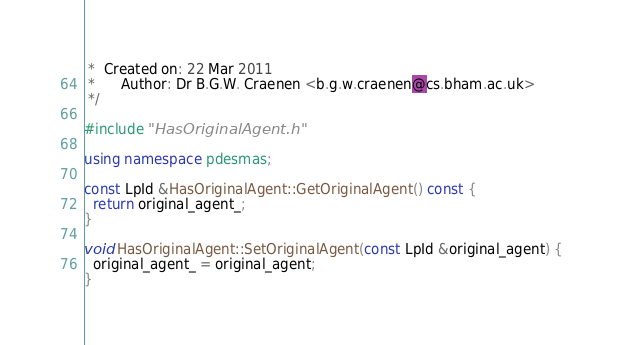<code> <loc_0><loc_0><loc_500><loc_500><_C++_> *  Created on: 22 Mar 2011
 *      Author: Dr B.G.W. Craenen <b.g.w.craenen@cs.bham.ac.uk>
 */

#include "HasOriginalAgent.h"

using namespace pdesmas;

const LpId &HasOriginalAgent::GetOriginalAgent() const {
  return original_agent_;
}

void HasOriginalAgent::SetOriginalAgent(const LpId &original_agent) {
  original_agent_ = original_agent;
}
</code> 